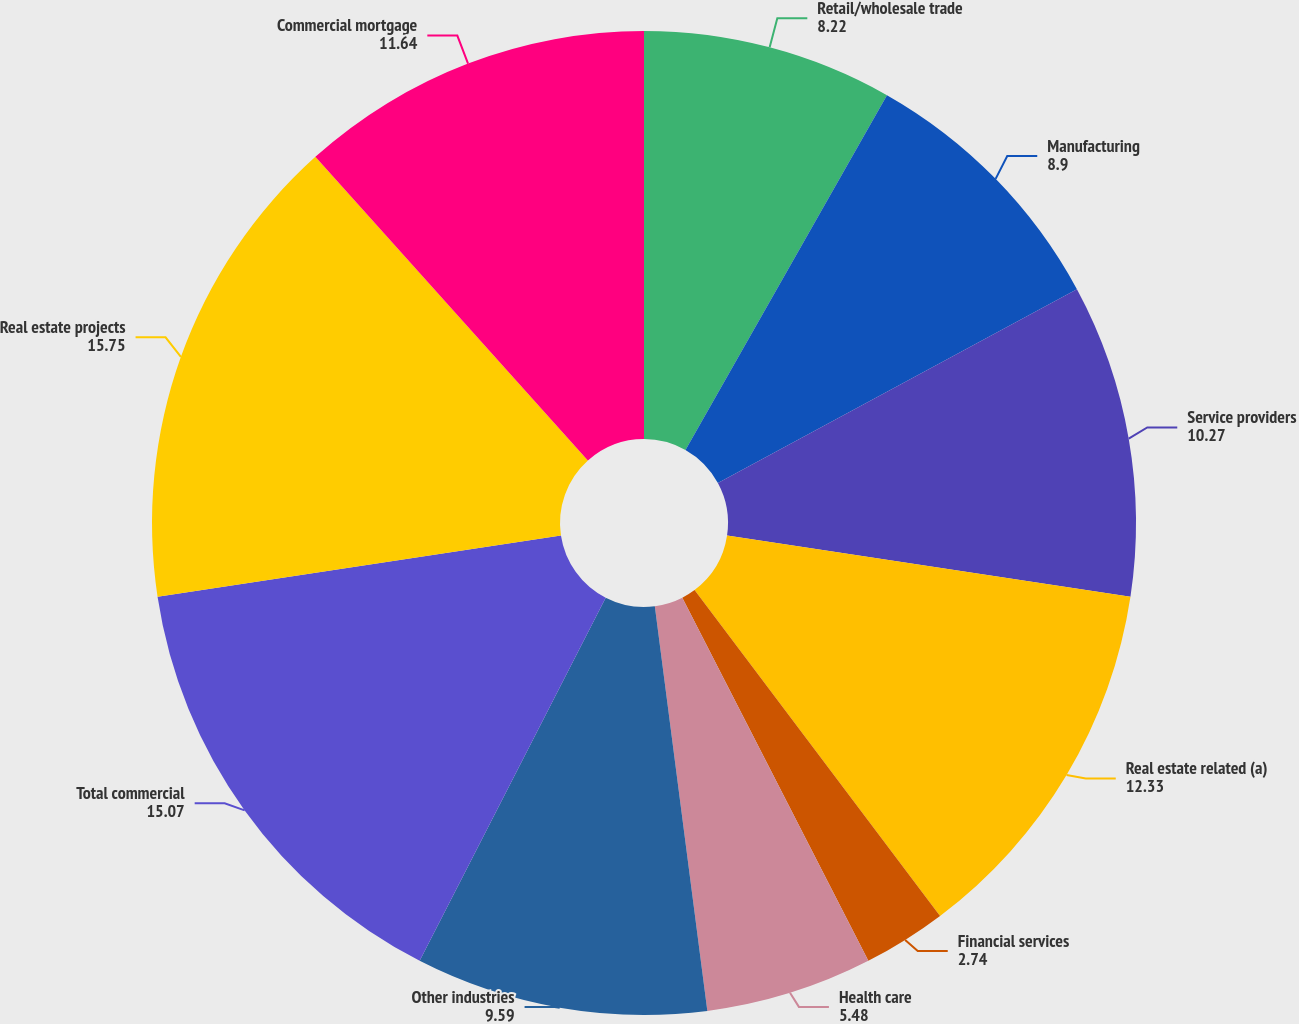<chart> <loc_0><loc_0><loc_500><loc_500><pie_chart><fcel>Retail/wholesale trade<fcel>Manufacturing<fcel>Service providers<fcel>Real estate related (a)<fcel>Financial services<fcel>Health care<fcel>Other industries<fcel>Total commercial<fcel>Real estate projects<fcel>Commercial mortgage<nl><fcel>8.22%<fcel>8.9%<fcel>10.27%<fcel>12.33%<fcel>2.74%<fcel>5.48%<fcel>9.59%<fcel>15.07%<fcel>15.75%<fcel>11.64%<nl></chart> 